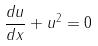<formula> <loc_0><loc_0><loc_500><loc_500>\frac { d u } { d x } + u ^ { 2 } = 0</formula> 